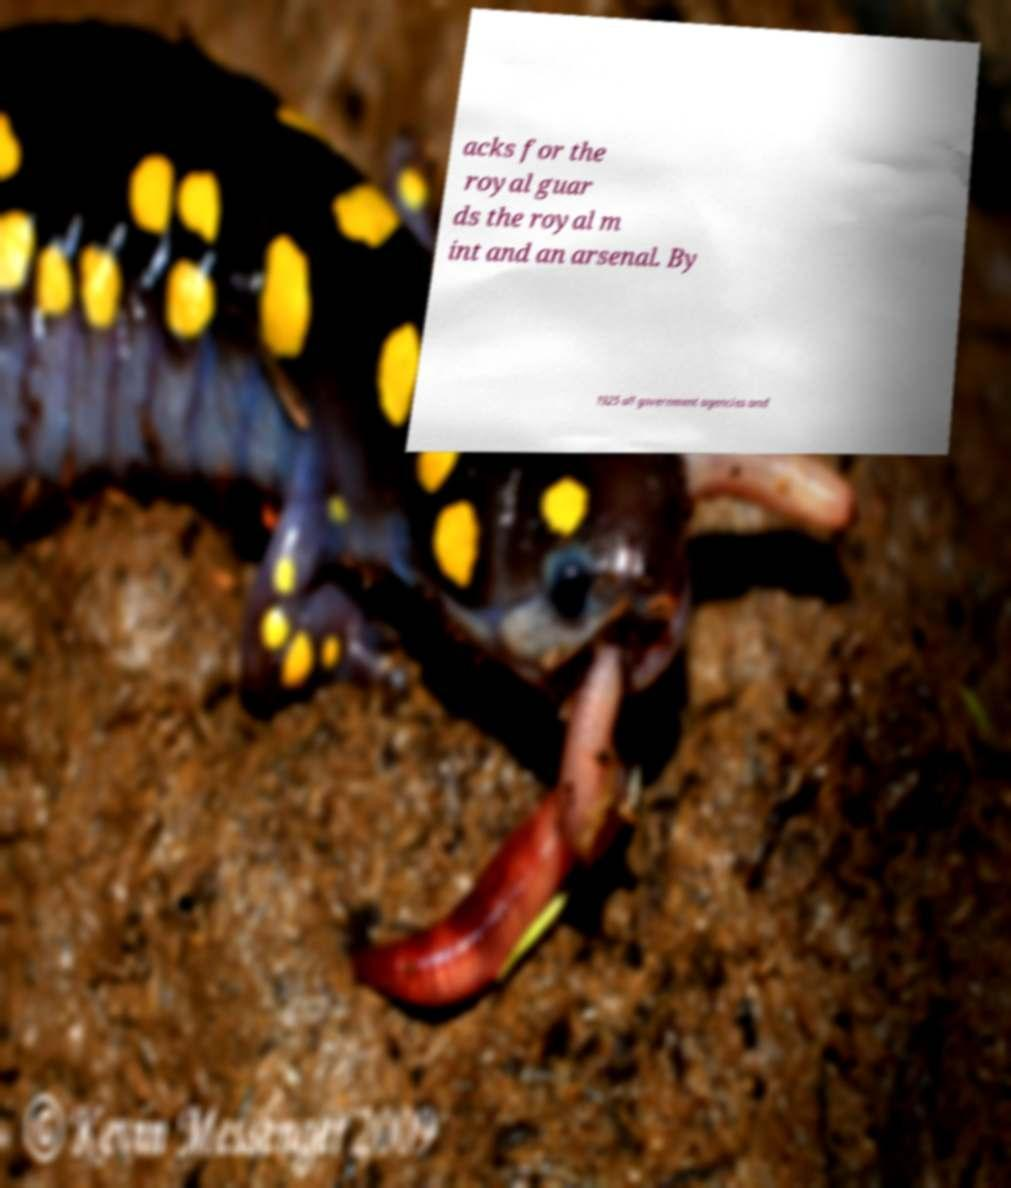Can you read and provide the text displayed in the image?This photo seems to have some interesting text. Can you extract and type it out for me? acks for the royal guar ds the royal m int and an arsenal. By 1925 all government agencies and 